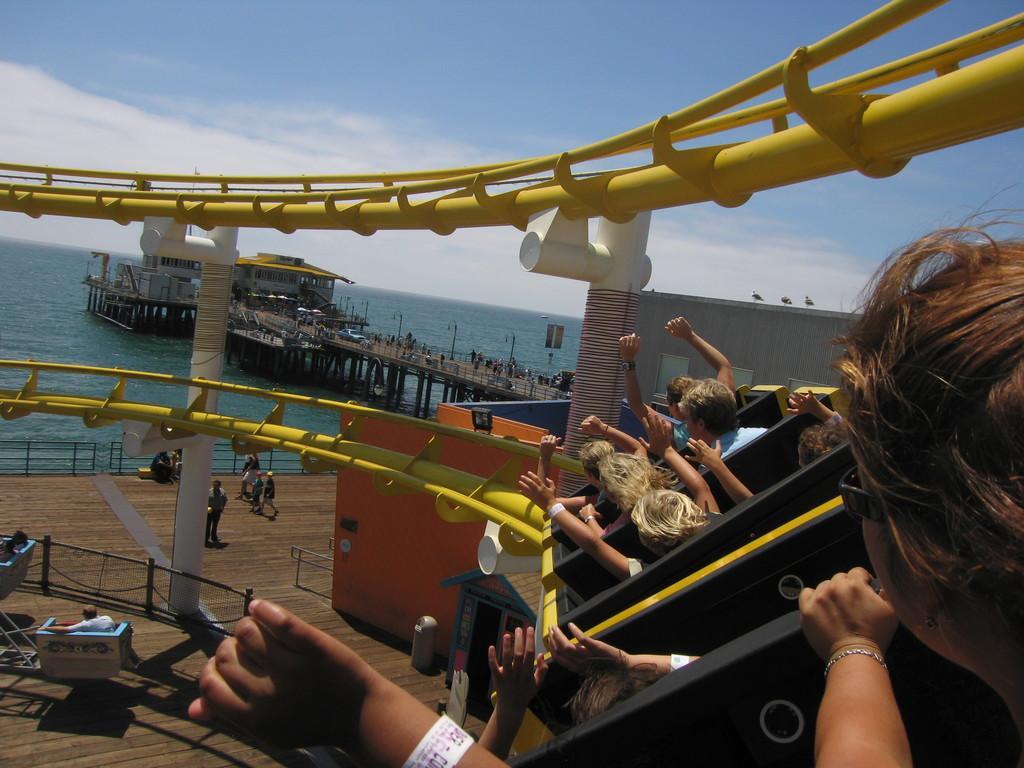Could you give a brief overview of what you see in this image? This image consists of many people. It looks like a roller coaster. The track is in yellow color. And it is clicked near the ocean. In the front, we can see a building and a bridge made up of wood. At the bottom, there is a fencing. At the top, there are clouds in the sky. In the background, there is water. 